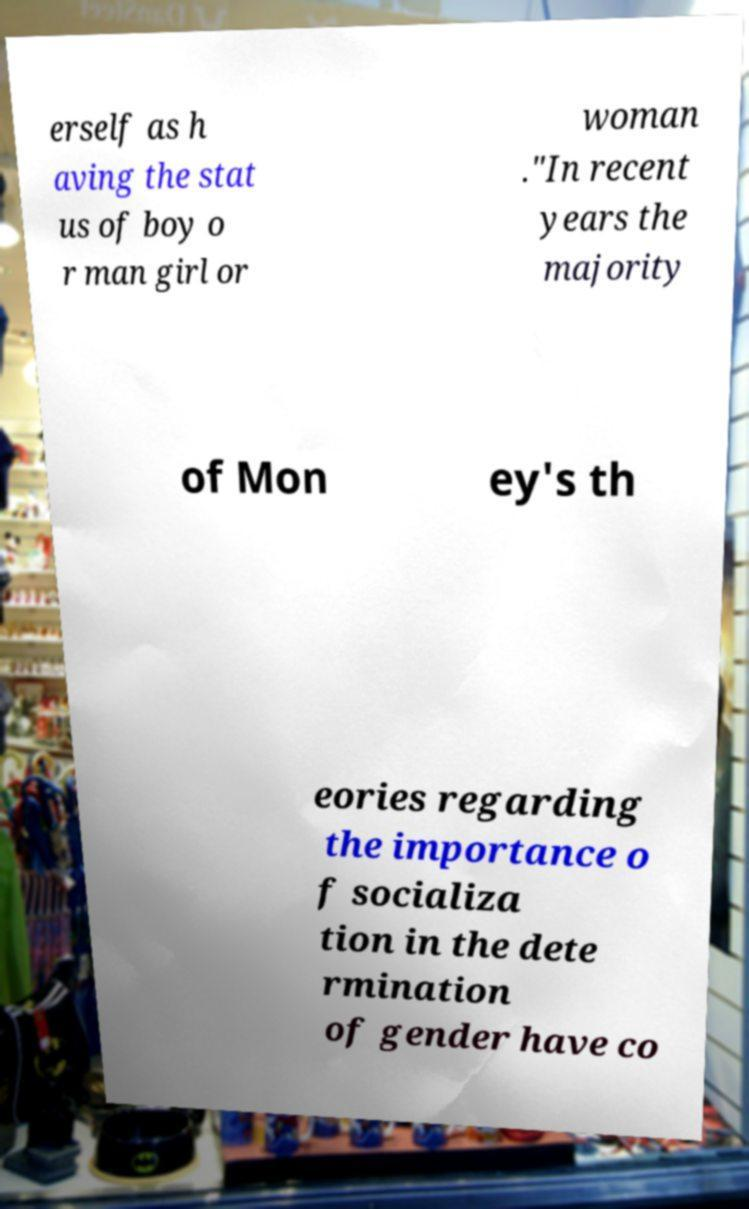For documentation purposes, I need the text within this image transcribed. Could you provide that? erself as h aving the stat us of boy o r man girl or woman ."In recent years the majority of Mon ey's th eories regarding the importance o f socializa tion in the dete rmination of gender have co 